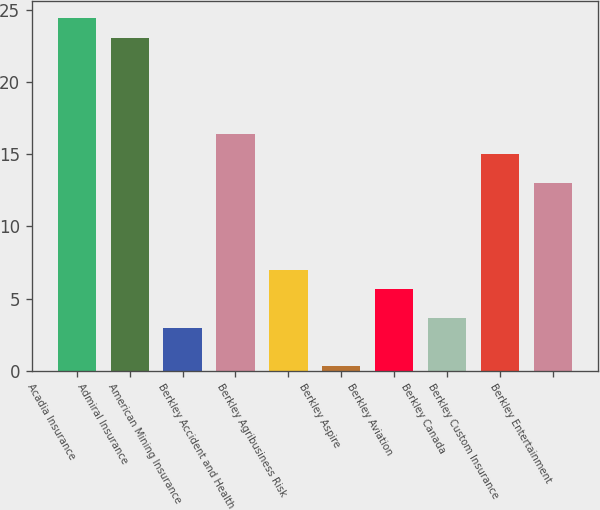Convert chart to OTSL. <chart><loc_0><loc_0><loc_500><loc_500><bar_chart><fcel>Acadia Insurance<fcel>Admiral Insurance<fcel>American Mining Insurance<fcel>Berkley Accident and Health<fcel>Berkley Agribusiness Risk<fcel>Berkley Aspire<fcel>Berkley Aviation<fcel>Berkley Canada<fcel>Berkley Custom Insurance<fcel>Berkley Entertainment<nl><fcel>24.42<fcel>23.08<fcel>2.98<fcel>16.38<fcel>7<fcel>0.3<fcel>5.66<fcel>3.65<fcel>15.04<fcel>13.03<nl></chart> 